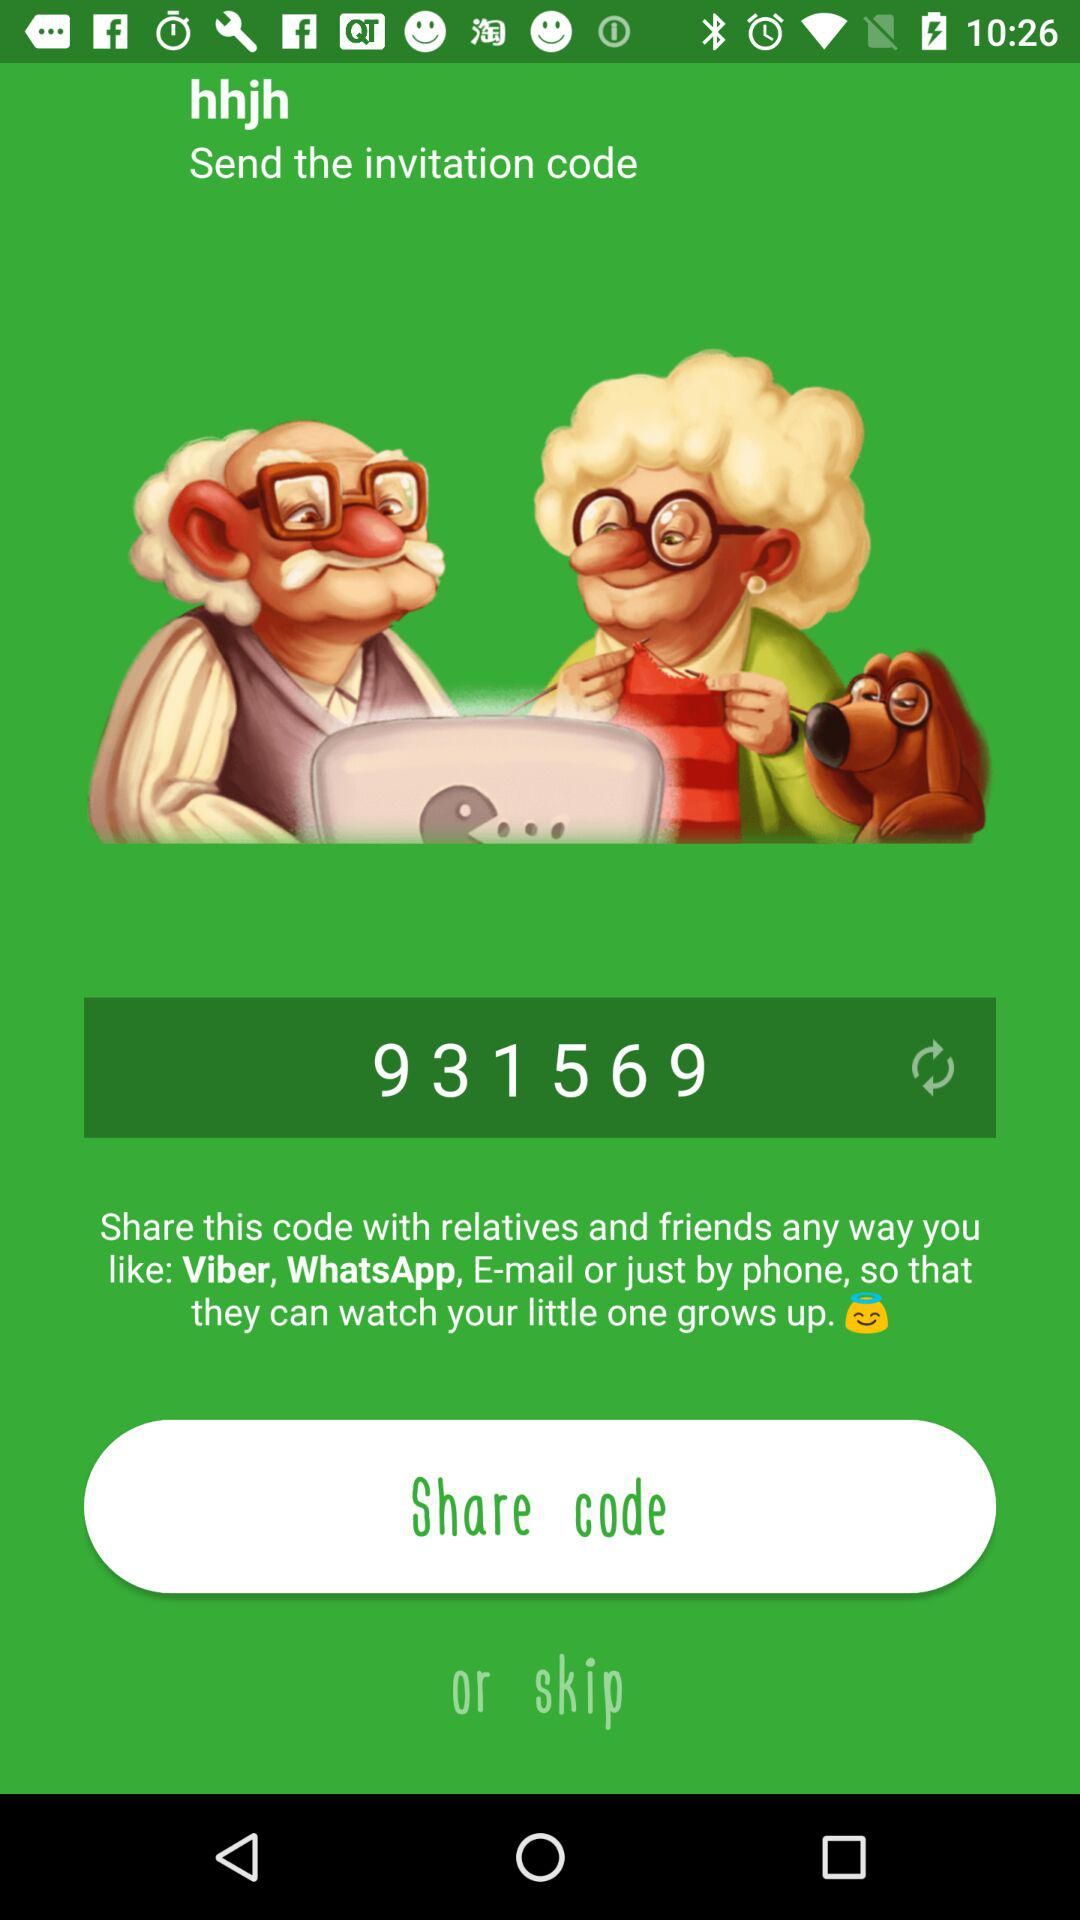What is the invitation code? The invitation code is 931569. 